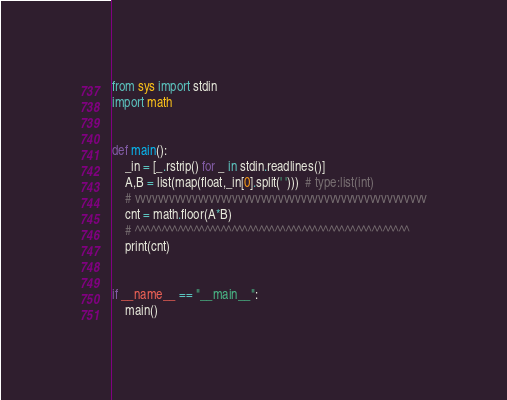Convert code to text. <code><loc_0><loc_0><loc_500><loc_500><_Python_>from sys import stdin
import math


def main():
    _in = [_.rstrip() for _ in stdin.readlines()]
    A,B = list(map(float,_in[0].split(' ')))  # type:list(int)
    # vvvvvvvvvvvvvvvvvvvvvvvvvvvvvvvvvvvvvvvvvvvvvvvvvvv
    cnt = math.floor(A*B)
    # ^^^^^^^^^^^^^^^^^^^^^^^^^^^^^^^^^^^^^^^^^^^^^^^^^^^
    print(cnt)


if __name__ == "__main__":
    main()
</code> 